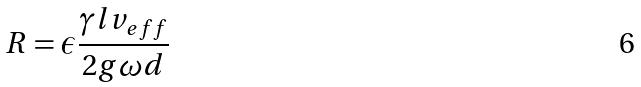Convert formula to latex. <formula><loc_0><loc_0><loc_500><loc_500>R = \epsilon \frac { \gamma l v _ { e f f } } { 2 g \omega d }</formula> 